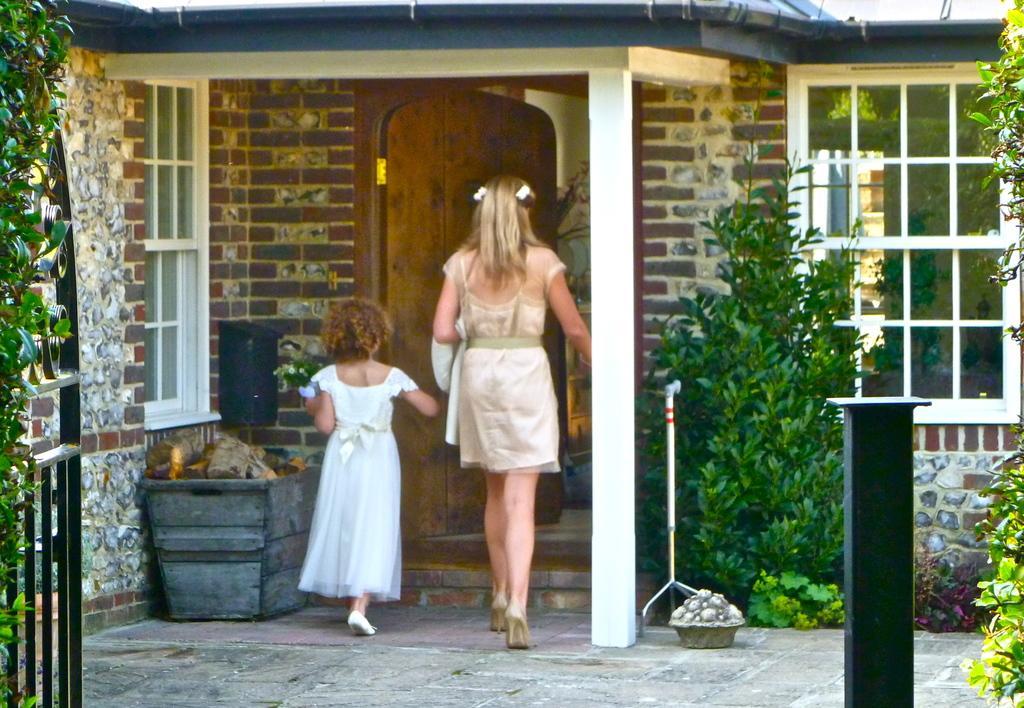Describe this image in one or two sentences. In this image I can see two persons walking, the person at right is wearing cream color dress and the person is left is wearing white color dress. Background I can see the house and the house is in brown and cream color and I can also see few glass doors, few plants in green color and I can also see the railing. 